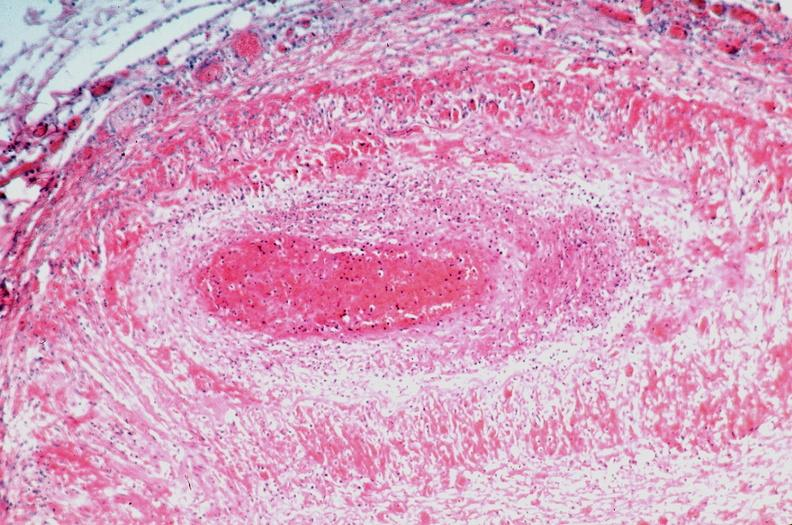s vasculature present?
Answer the question using a single word or phrase. Yes 